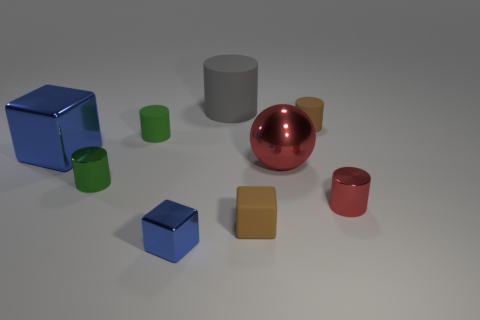Are there more large red metal spheres that are on the right side of the large rubber cylinder than big cyan blocks?
Give a very brief answer. Yes. What number of small metallic cubes are the same color as the large matte cylinder?
Make the answer very short. 0. What number of other things are the same color as the metallic sphere?
Make the answer very short. 1. Is the number of blue shiny blocks greater than the number of small shiny cubes?
Your response must be concise. Yes. What is the material of the large red thing?
Provide a short and direct response. Metal. There is a brown thing that is in front of the green rubber cylinder; is it the same size as the small red shiny cylinder?
Make the answer very short. Yes. There is a brown matte thing in front of the small red shiny cylinder; what is its size?
Your answer should be compact. Small. What number of brown cubes are there?
Offer a terse response. 1. Do the tiny metallic cube and the large cube have the same color?
Give a very brief answer. Yes. There is a block that is to the left of the gray matte cylinder and in front of the large red metal sphere; what is its color?
Your answer should be compact. Blue. 